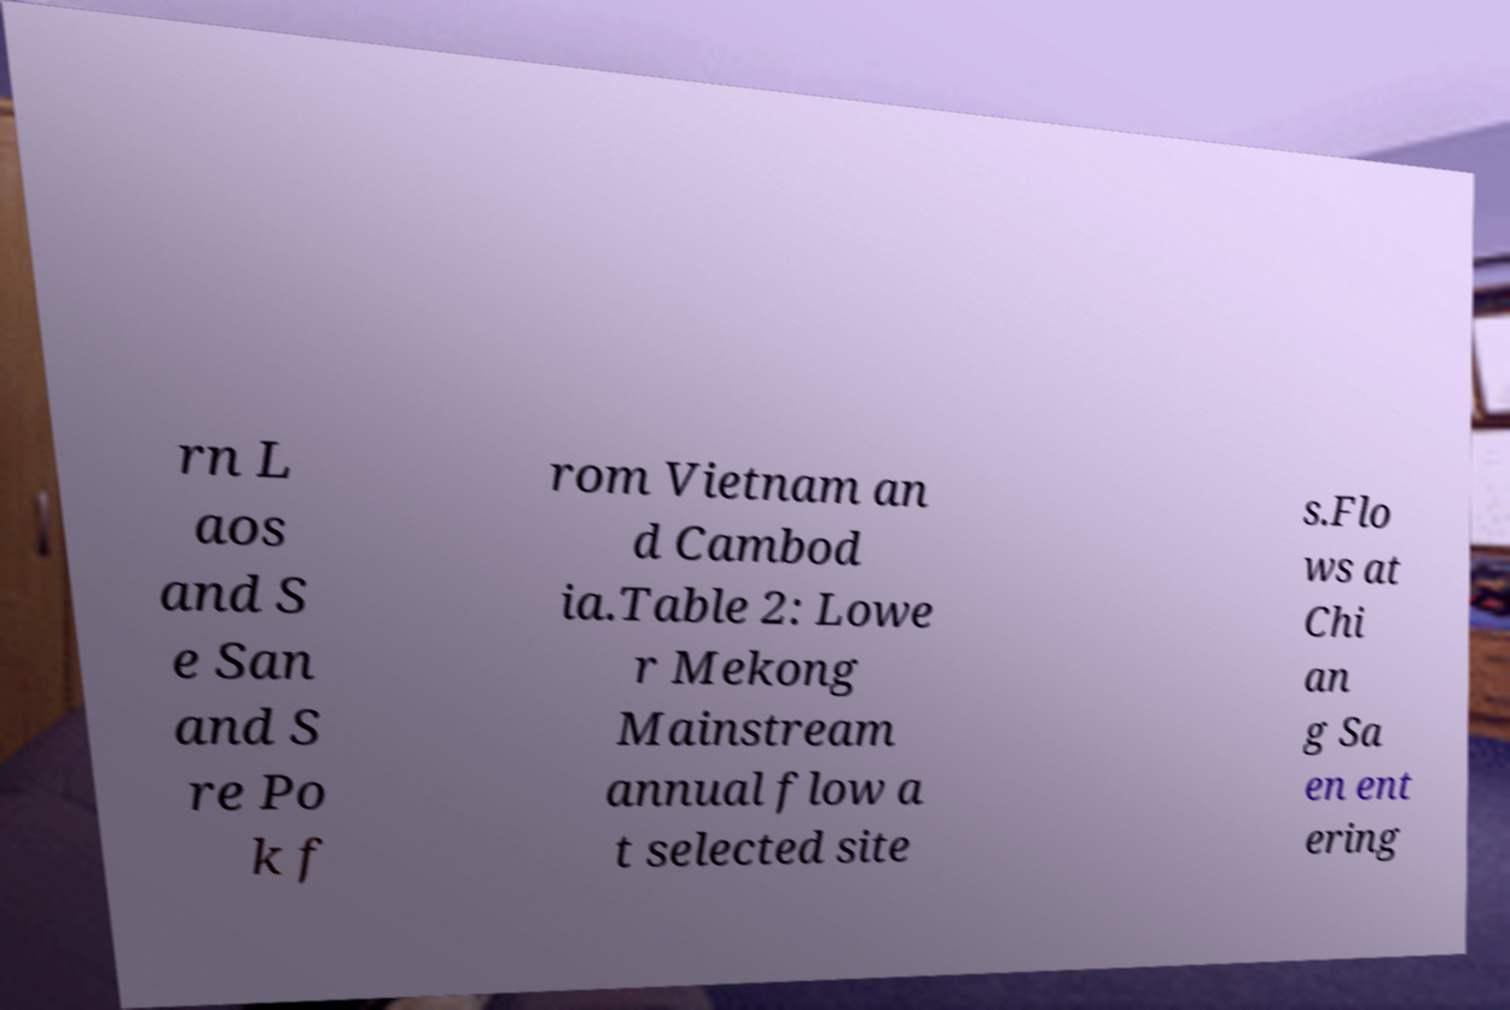Can you accurately transcribe the text from the provided image for me? rn L aos and S e San and S re Po k f rom Vietnam an d Cambod ia.Table 2: Lowe r Mekong Mainstream annual flow a t selected site s.Flo ws at Chi an g Sa en ent ering 